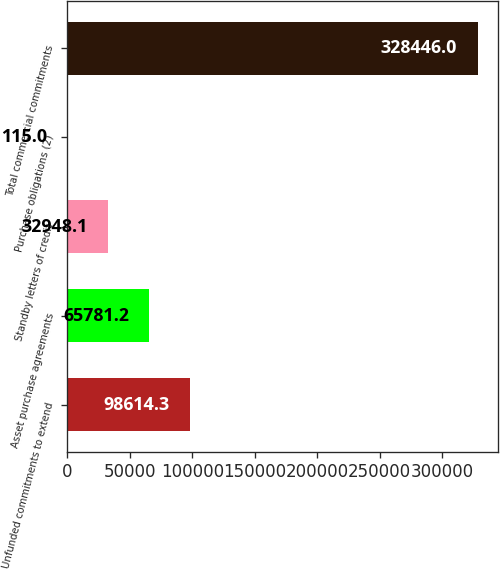<chart> <loc_0><loc_0><loc_500><loc_500><bar_chart><fcel>Unfunded commitments to extend<fcel>Asset purchase agreements<fcel>Standby letters of credit<fcel>Purchase obligations (2)<fcel>Total commercial commitments<nl><fcel>98614.3<fcel>65781.2<fcel>32948.1<fcel>115<fcel>328446<nl></chart> 